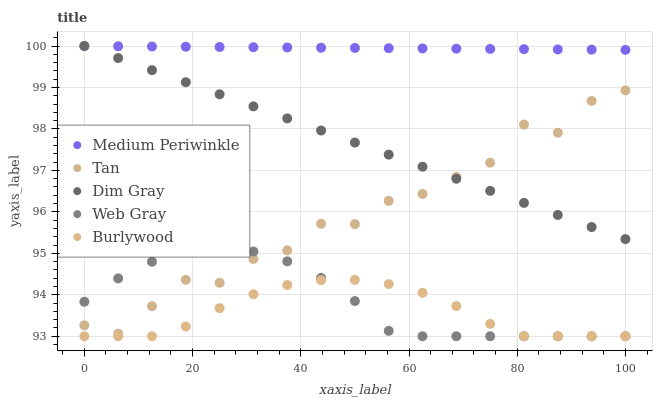Does Burlywood have the minimum area under the curve?
Answer yes or no. Yes. Does Medium Periwinkle have the maximum area under the curve?
Answer yes or no. Yes. Does Tan have the minimum area under the curve?
Answer yes or no. No. Does Tan have the maximum area under the curve?
Answer yes or no. No. Is Medium Periwinkle the smoothest?
Answer yes or no. Yes. Is Tan the roughest?
Answer yes or no. Yes. Is Burlywood the smoothest?
Answer yes or no. No. Is Burlywood the roughest?
Answer yes or no. No. Does Web Gray have the lowest value?
Answer yes or no. Yes. Does Tan have the lowest value?
Answer yes or no. No. Does Medium Periwinkle have the highest value?
Answer yes or no. Yes. Does Tan have the highest value?
Answer yes or no. No. Is Tan less than Medium Periwinkle?
Answer yes or no. Yes. Is Medium Periwinkle greater than Tan?
Answer yes or no. Yes. Does Dim Gray intersect Tan?
Answer yes or no. Yes. Is Dim Gray less than Tan?
Answer yes or no. No. Is Dim Gray greater than Tan?
Answer yes or no. No. Does Tan intersect Medium Periwinkle?
Answer yes or no. No. 